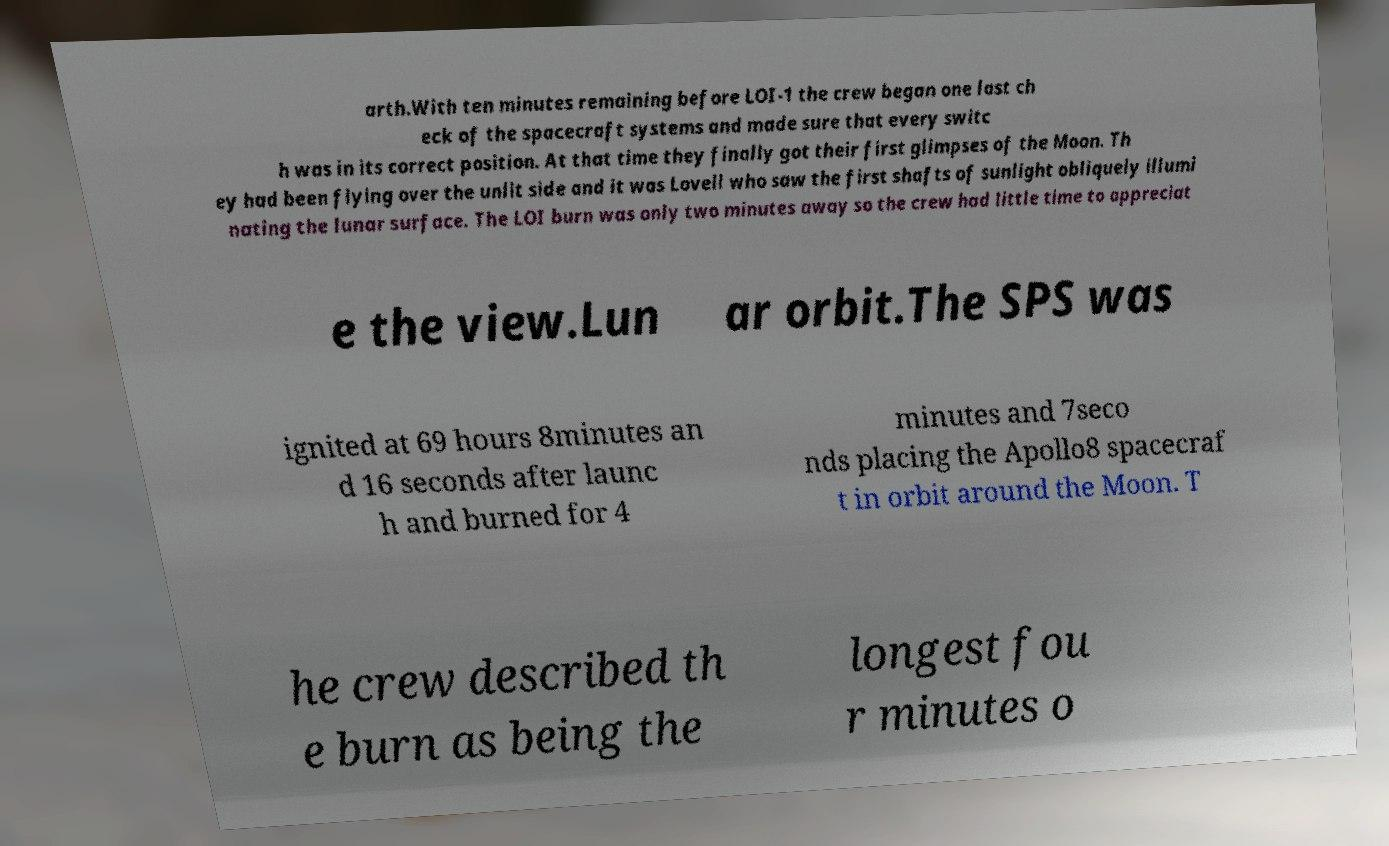There's text embedded in this image that I need extracted. Can you transcribe it verbatim? arth.With ten minutes remaining before LOI-1 the crew began one last ch eck of the spacecraft systems and made sure that every switc h was in its correct position. At that time they finally got their first glimpses of the Moon. Th ey had been flying over the unlit side and it was Lovell who saw the first shafts of sunlight obliquely illumi nating the lunar surface. The LOI burn was only two minutes away so the crew had little time to appreciat e the view.Lun ar orbit.The SPS was ignited at 69 hours 8minutes an d 16 seconds after launc h and burned for 4 minutes and 7seco nds placing the Apollo8 spacecraf t in orbit around the Moon. T he crew described th e burn as being the longest fou r minutes o 